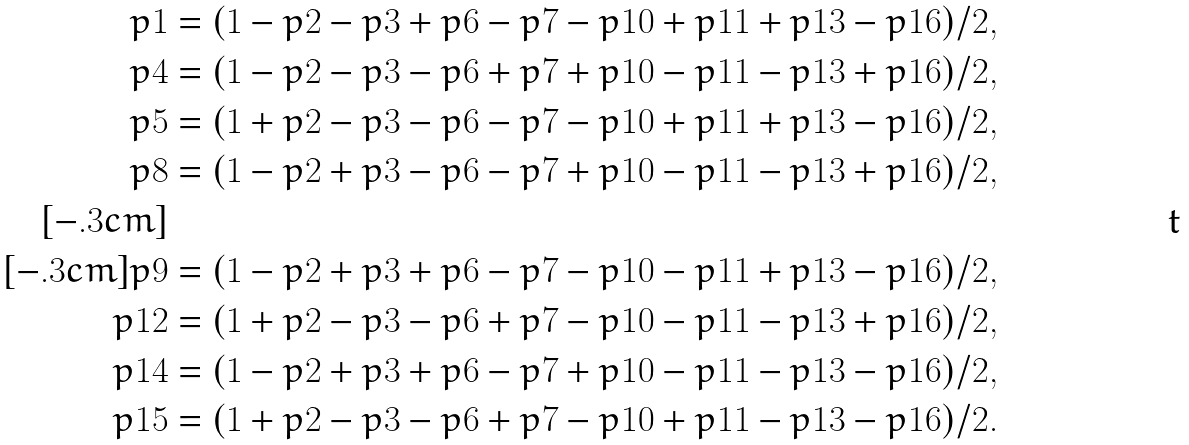Convert formula to latex. <formula><loc_0><loc_0><loc_500><loc_500>p 1 & = ( 1 - p 2 - p 3 + p 6 - p 7 - p 1 0 + p 1 1 + p 1 3 - p 1 6 ) / 2 , \\ p 4 & = ( 1 - p 2 - p 3 - p 6 + p 7 + p 1 0 - p 1 1 - p 1 3 + p 1 6 ) / 2 , \\ p 5 & = ( 1 + p 2 - p 3 - p 6 - p 7 - p 1 0 + p 1 1 + p 1 3 - p 1 6 ) / 2 , \\ p 8 & = ( 1 - p 2 + p 3 - p 6 - p 7 + p 1 0 - p 1 1 - p 1 3 + p 1 6 ) / 2 , \\ [ - . 3 c m ] & \\ [ - . 3 c m ] p 9 & = ( 1 - p 2 + p 3 + p 6 - p 7 - p 1 0 - p 1 1 + p 1 3 - p 1 6 ) / 2 , \\ p 1 2 & = ( 1 + p 2 - p 3 - p 6 + p 7 - p 1 0 - p 1 1 - p 1 3 + p 1 6 ) / 2 , \\ p 1 4 & = ( 1 - p 2 + p 3 + p 6 - p 7 + p 1 0 - p 1 1 - p 1 3 - p 1 6 ) / 2 , \\ p 1 5 & = ( 1 + p 2 - p 3 - p 6 + p 7 - p 1 0 + p 1 1 - p 1 3 - p 1 6 ) / 2 .</formula> 